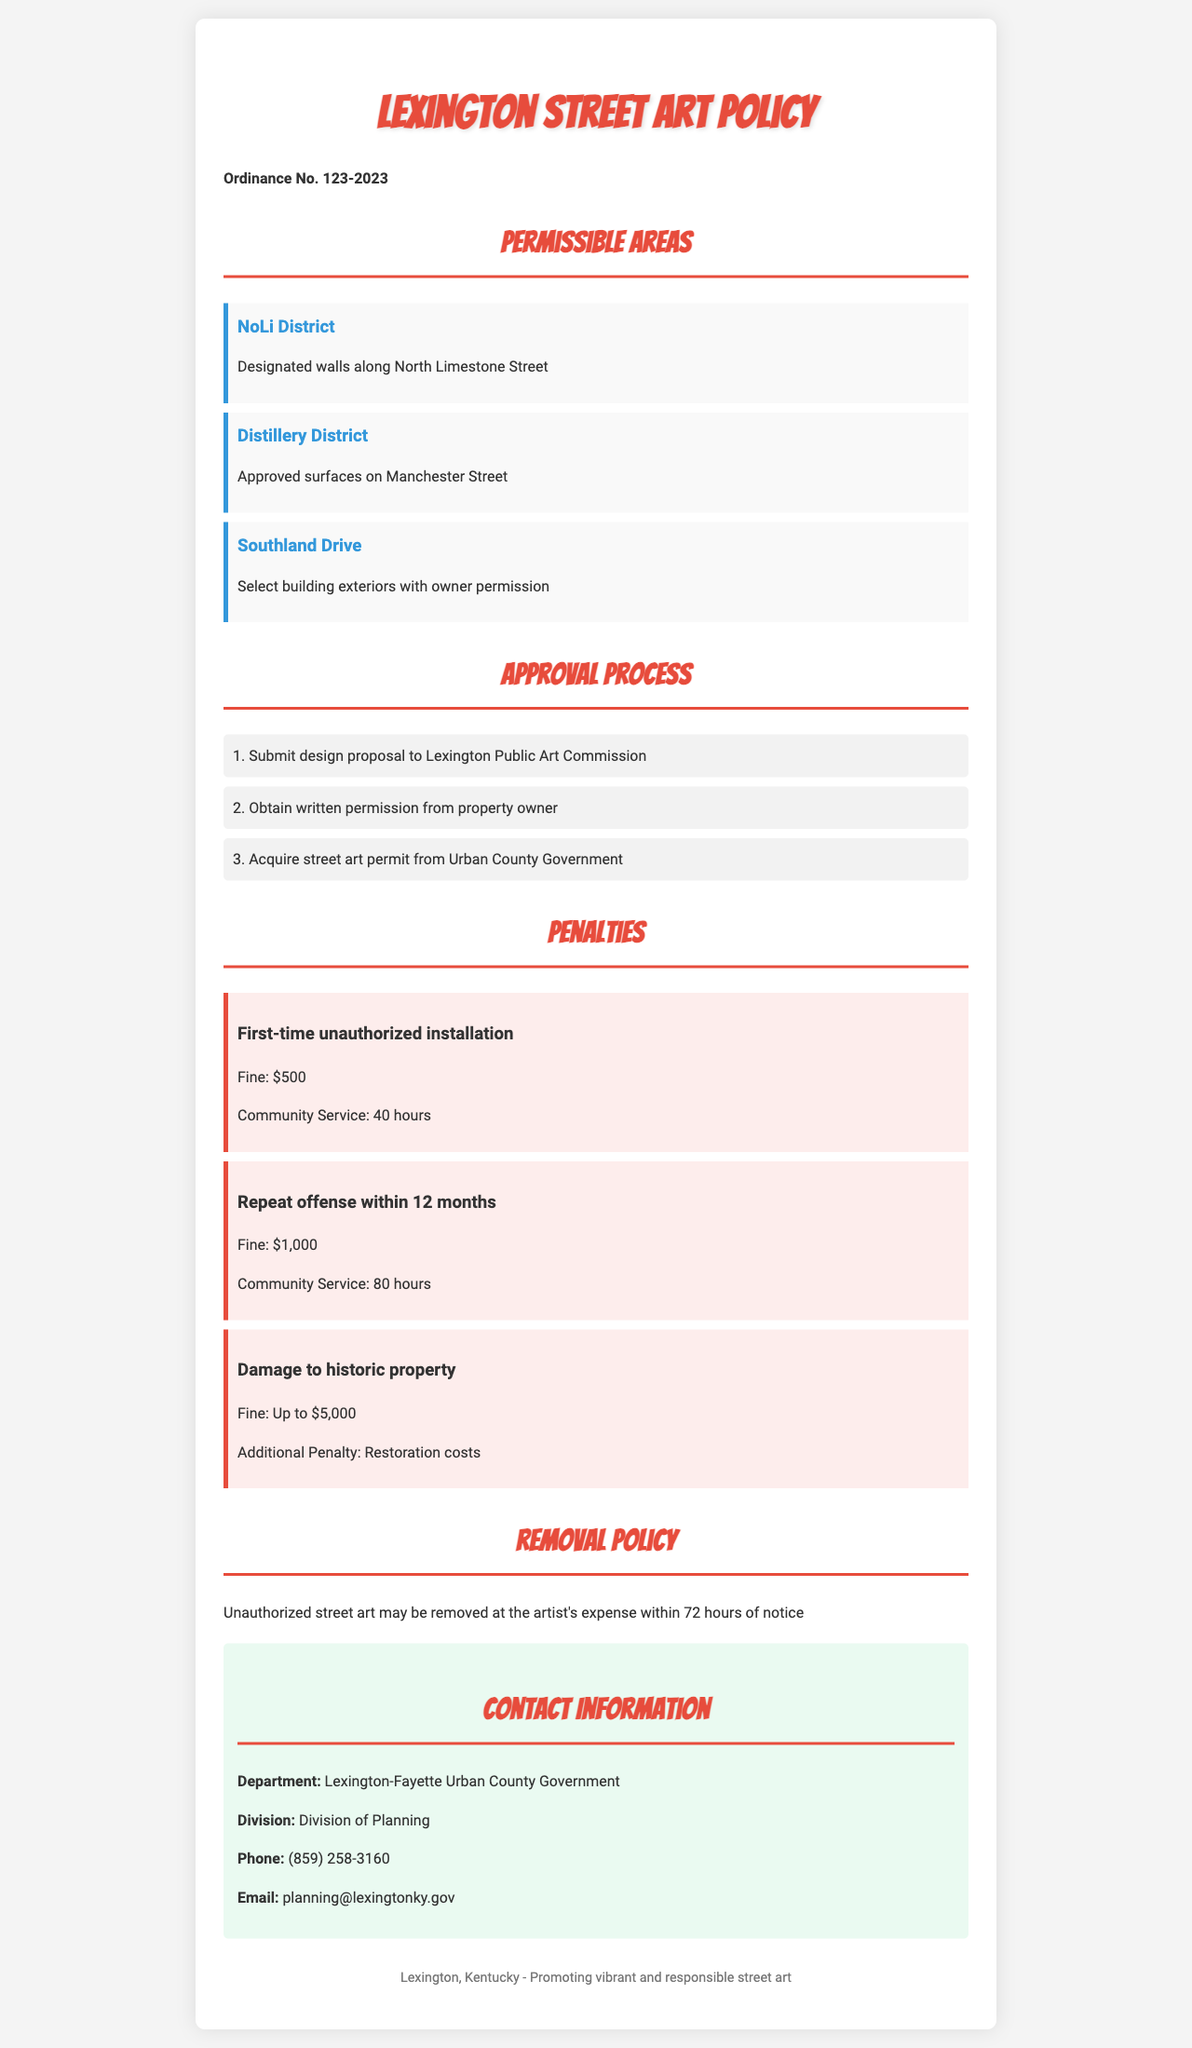What are the permissible areas for street art? The document lists specific locations designated for street art, including NoLi District, Distillery District, and Southland Drive.
Answer: NoLi District, Distillery District, Southland Drive What is the fine for a first-time unauthorized installation? The document specifies the penalty associated with a first-time unauthorized installation, which includes a fine.
Answer: $500 How many hours of community service is required for a repeat offense? The document provides the community service requirement for those who commit a repeat offense within 12 months.
Answer: 80 hours What is the process for obtaining a street art permit? The document outlines three steps in the approval process for street art, detailing what is needed to obtain a permit.
Answer: Submit design proposal, obtain written permission, acquire street art permit What is the maximum penalty for damage to historic property? The document indicates the financial repercussions for damaging historic property when unauthorized street art is involved.
Answer: Up to $5,000 How long after notice can unauthorized street art be removed? The document mentions the timeframe allowed for removal of unauthorized street art after receiving notice.
Answer: 72 hours Who should be contacted for more information? The document specifies the department and division to contact for additional inquiries regarding street art policies.
Answer: Lexington-Fayette Urban County Government, Division of Planning What email address is provided for inquiries about street art? The document includes a specific email address for contacting the Division of Planning with questions related to street art.
Answer: planning@lexingtonky.gov 